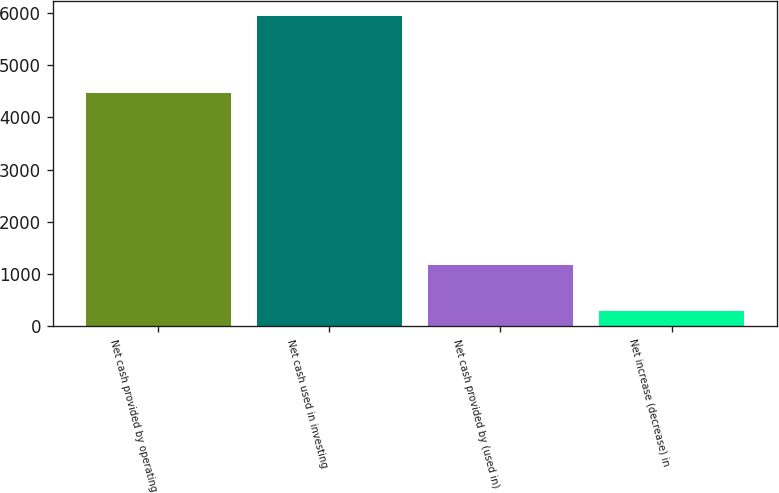Convert chart to OTSL. <chart><loc_0><loc_0><loc_500><loc_500><bar_chart><fcel>Net cash provided by operating<fcel>Net cash used in investing<fcel>Net cash provided by (used in)<fcel>Net increase (decrease) in<nl><fcel>4463<fcel>5935<fcel>1175<fcel>297<nl></chart> 